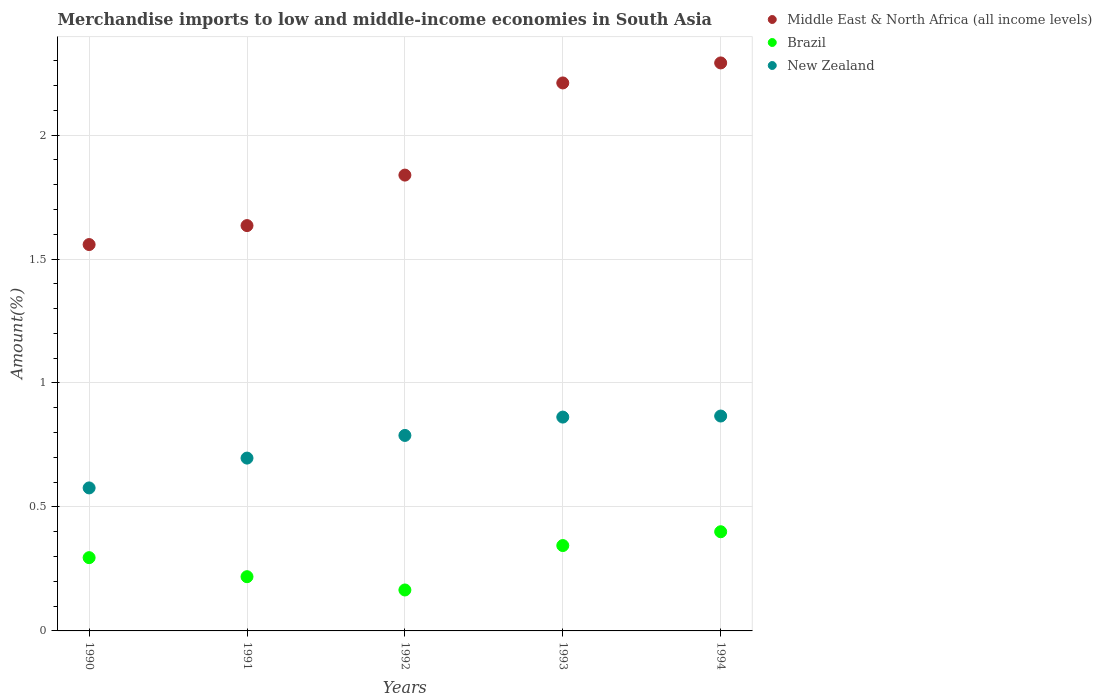What is the percentage of amount earned from merchandise imports in Brazil in 1993?
Give a very brief answer. 0.34. Across all years, what is the maximum percentage of amount earned from merchandise imports in Brazil?
Offer a very short reply. 0.4. Across all years, what is the minimum percentage of amount earned from merchandise imports in Middle East & North Africa (all income levels)?
Offer a very short reply. 1.56. In which year was the percentage of amount earned from merchandise imports in New Zealand maximum?
Your response must be concise. 1994. What is the total percentage of amount earned from merchandise imports in New Zealand in the graph?
Provide a succinct answer. 3.79. What is the difference between the percentage of amount earned from merchandise imports in Brazil in 1990 and that in 1993?
Ensure brevity in your answer.  -0.05. What is the difference between the percentage of amount earned from merchandise imports in New Zealand in 1991 and the percentage of amount earned from merchandise imports in Brazil in 1992?
Keep it short and to the point. 0.53. What is the average percentage of amount earned from merchandise imports in New Zealand per year?
Offer a terse response. 0.76. In the year 1993, what is the difference between the percentage of amount earned from merchandise imports in New Zealand and percentage of amount earned from merchandise imports in Brazil?
Provide a short and direct response. 0.52. In how many years, is the percentage of amount earned from merchandise imports in Middle East & North Africa (all income levels) greater than 1 %?
Make the answer very short. 5. What is the ratio of the percentage of amount earned from merchandise imports in New Zealand in 1992 to that in 1993?
Make the answer very short. 0.91. Is the difference between the percentage of amount earned from merchandise imports in New Zealand in 1991 and 1993 greater than the difference between the percentage of amount earned from merchandise imports in Brazil in 1991 and 1993?
Keep it short and to the point. No. What is the difference between the highest and the second highest percentage of amount earned from merchandise imports in New Zealand?
Keep it short and to the point. 0. What is the difference between the highest and the lowest percentage of amount earned from merchandise imports in Middle East & North Africa (all income levels)?
Ensure brevity in your answer.  0.73. In how many years, is the percentage of amount earned from merchandise imports in New Zealand greater than the average percentage of amount earned from merchandise imports in New Zealand taken over all years?
Your answer should be compact. 3. Is it the case that in every year, the sum of the percentage of amount earned from merchandise imports in Brazil and percentage of amount earned from merchandise imports in New Zealand  is greater than the percentage of amount earned from merchandise imports in Middle East & North Africa (all income levels)?
Your answer should be compact. No. Does the percentage of amount earned from merchandise imports in Brazil monotonically increase over the years?
Offer a terse response. No. Is the percentage of amount earned from merchandise imports in Middle East & North Africa (all income levels) strictly greater than the percentage of amount earned from merchandise imports in New Zealand over the years?
Provide a short and direct response. Yes. How many years are there in the graph?
Make the answer very short. 5. Are the values on the major ticks of Y-axis written in scientific E-notation?
Provide a succinct answer. No. Does the graph contain any zero values?
Your answer should be very brief. No. Where does the legend appear in the graph?
Keep it short and to the point. Top right. How are the legend labels stacked?
Provide a short and direct response. Vertical. What is the title of the graph?
Offer a terse response. Merchandise imports to low and middle-income economies in South Asia. What is the label or title of the Y-axis?
Offer a terse response. Amount(%). What is the Amount(%) of Middle East & North Africa (all income levels) in 1990?
Ensure brevity in your answer.  1.56. What is the Amount(%) in Brazil in 1990?
Provide a succinct answer. 0.3. What is the Amount(%) in New Zealand in 1990?
Ensure brevity in your answer.  0.58. What is the Amount(%) of Middle East & North Africa (all income levels) in 1991?
Your response must be concise. 1.63. What is the Amount(%) in Brazil in 1991?
Your response must be concise. 0.22. What is the Amount(%) of New Zealand in 1991?
Your response must be concise. 0.7. What is the Amount(%) in Middle East & North Africa (all income levels) in 1992?
Ensure brevity in your answer.  1.84. What is the Amount(%) of Brazil in 1992?
Provide a short and direct response. 0.17. What is the Amount(%) in New Zealand in 1992?
Your answer should be very brief. 0.79. What is the Amount(%) of Middle East & North Africa (all income levels) in 1993?
Ensure brevity in your answer.  2.21. What is the Amount(%) of Brazil in 1993?
Your response must be concise. 0.34. What is the Amount(%) in New Zealand in 1993?
Ensure brevity in your answer.  0.86. What is the Amount(%) of Middle East & North Africa (all income levels) in 1994?
Keep it short and to the point. 2.29. What is the Amount(%) in Brazil in 1994?
Ensure brevity in your answer.  0.4. What is the Amount(%) of New Zealand in 1994?
Ensure brevity in your answer.  0.87. Across all years, what is the maximum Amount(%) in Middle East & North Africa (all income levels)?
Give a very brief answer. 2.29. Across all years, what is the maximum Amount(%) in Brazil?
Provide a succinct answer. 0.4. Across all years, what is the maximum Amount(%) of New Zealand?
Give a very brief answer. 0.87. Across all years, what is the minimum Amount(%) of Middle East & North Africa (all income levels)?
Offer a terse response. 1.56. Across all years, what is the minimum Amount(%) of Brazil?
Make the answer very short. 0.17. Across all years, what is the minimum Amount(%) of New Zealand?
Ensure brevity in your answer.  0.58. What is the total Amount(%) of Middle East & North Africa (all income levels) in the graph?
Offer a very short reply. 9.53. What is the total Amount(%) in Brazil in the graph?
Your answer should be very brief. 1.42. What is the total Amount(%) of New Zealand in the graph?
Your answer should be very brief. 3.79. What is the difference between the Amount(%) in Middle East & North Africa (all income levels) in 1990 and that in 1991?
Give a very brief answer. -0.08. What is the difference between the Amount(%) in Brazil in 1990 and that in 1991?
Your response must be concise. 0.08. What is the difference between the Amount(%) of New Zealand in 1990 and that in 1991?
Your answer should be very brief. -0.12. What is the difference between the Amount(%) in Middle East & North Africa (all income levels) in 1990 and that in 1992?
Ensure brevity in your answer.  -0.28. What is the difference between the Amount(%) of Brazil in 1990 and that in 1992?
Your answer should be compact. 0.13. What is the difference between the Amount(%) in New Zealand in 1990 and that in 1992?
Make the answer very short. -0.21. What is the difference between the Amount(%) of Middle East & North Africa (all income levels) in 1990 and that in 1993?
Offer a very short reply. -0.65. What is the difference between the Amount(%) of Brazil in 1990 and that in 1993?
Give a very brief answer. -0.05. What is the difference between the Amount(%) in New Zealand in 1990 and that in 1993?
Offer a very short reply. -0.29. What is the difference between the Amount(%) in Middle East & North Africa (all income levels) in 1990 and that in 1994?
Your answer should be very brief. -0.73. What is the difference between the Amount(%) of Brazil in 1990 and that in 1994?
Ensure brevity in your answer.  -0.1. What is the difference between the Amount(%) in New Zealand in 1990 and that in 1994?
Offer a terse response. -0.29. What is the difference between the Amount(%) in Middle East & North Africa (all income levels) in 1991 and that in 1992?
Your answer should be compact. -0.2. What is the difference between the Amount(%) of Brazil in 1991 and that in 1992?
Your response must be concise. 0.05. What is the difference between the Amount(%) of New Zealand in 1991 and that in 1992?
Make the answer very short. -0.09. What is the difference between the Amount(%) of Middle East & North Africa (all income levels) in 1991 and that in 1993?
Your response must be concise. -0.58. What is the difference between the Amount(%) of Brazil in 1991 and that in 1993?
Offer a terse response. -0.13. What is the difference between the Amount(%) of New Zealand in 1991 and that in 1993?
Keep it short and to the point. -0.17. What is the difference between the Amount(%) of Middle East & North Africa (all income levels) in 1991 and that in 1994?
Your response must be concise. -0.66. What is the difference between the Amount(%) in Brazil in 1991 and that in 1994?
Your answer should be very brief. -0.18. What is the difference between the Amount(%) of New Zealand in 1991 and that in 1994?
Your response must be concise. -0.17. What is the difference between the Amount(%) of Middle East & North Africa (all income levels) in 1992 and that in 1993?
Provide a short and direct response. -0.37. What is the difference between the Amount(%) in Brazil in 1992 and that in 1993?
Keep it short and to the point. -0.18. What is the difference between the Amount(%) of New Zealand in 1992 and that in 1993?
Give a very brief answer. -0.07. What is the difference between the Amount(%) of Middle East & North Africa (all income levels) in 1992 and that in 1994?
Give a very brief answer. -0.45. What is the difference between the Amount(%) in Brazil in 1992 and that in 1994?
Offer a very short reply. -0.23. What is the difference between the Amount(%) in New Zealand in 1992 and that in 1994?
Provide a succinct answer. -0.08. What is the difference between the Amount(%) in Middle East & North Africa (all income levels) in 1993 and that in 1994?
Provide a succinct answer. -0.08. What is the difference between the Amount(%) of Brazil in 1993 and that in 1994?
Keep it short and to the point. -0.06. What is the difference between the Amount(%) of New Zealand in 1993 and that in 1994?
Give a very brief answer. -0. What is the difference between the Amount(%) of Middle East & North Africa (all income levels) in 1990 and the Amount(%) of Brazil in 1991?
Offer a terse response. 1.34. What is the difference between the Amount(%) in Middle East & North Africa (all income levels) in 1990 and the Amount(%) in New Zealand in 1991?
Your response must be concise. 0.86. What is the difference between the Amount(%) in Brazil in 1990 and the Amount(%) in New Zealand in 1991?
Ensure brevity in your answer.  -0.4. What is the difference between the Amount(%) of Middle East & North Africa (all income levels) in 1990 and the Amount(%) of Brazil in 1992?
Offer a very short reply. 1.39. What is the difference between the Amount(%) of Middle East & North Africa (all income levels) in 1990 and the Amount(%) of New Zealand in 1992?
Provide a short and direct response. 0.77. What is the difference between the Amount(%) in Brazil in 1990 and the Amount(%) in New Zealand in 1992?
Make the answer very short. -0.49. What is the difference between the Amount(%) of Middle East & North Africa (all income levels) in 1990 and the Amount(%) of Brazil in 1993?
Your answer should be very brief. 1.21. What is the difference between the Amount(%) in Middle East & North Africa (all income levels) in 1990 and the Amount(%) in New Zealand in 1993?
Provide a short and direct response. 0.7. What is the difference between the Amount(%) of Brazil in 1990 and the Amount(%) of New Zealand in 1993?
Offer a terse response. -0.57. What is the difference between the Amount(%) in Middle East & North Africa (all income levels) in 1990 and the Amount(%) in Brazil in 1994?
Provide a succinct answer. 1.16. What is the difference between the Amount(%) of Middle East & North Africa (all income levels) in 1990 and the Amount(%) of New Zealand in 1994?
Keep it short and to the point. 0.69. What is the difference between the Amount(%) in Brazil in 1990 and the Amount(%) in New Zealand in 1994?
Give a very brief answer. -0.57. What is the difference between the Amount(%) in Middle East & North Africa (all income levels) in 1991 and the Amount(%) in Brazil in 1992?
Keep it short and to the point. 1.47. What is the difference between the Amount(%) of Middle East & North Africa (all income levels) in 1991 and the Amount(%) of New Zealand in 1992?
Provide a succinct answer. 0.85. What is the difference between the Amount(%) in Brazil in 1991 and the Amount(%) in New Zealand in 1992?
Keep it short and to the point. -0.57. What is the difference between the Amount(%) in Middle East & North Africa (all income levels) in 1991 and the Amount(%) in Brazil in 1993?
Your answer should be very brief. 1.29. What is the difference between the Amount(%) in Middle East & North Africa (all income levels) in 1991 and the Amount(%) in New Zealand in 1993?
Your answer should be compact. 0.77. What is the difference between the Amount(%) in Brazil in 1991 and the Amount(%) in New Zealand in 1993?
Make the answer very short. -0.64. What is the difference between the Amount(%) of Middle East & North Africa (all income levels) in 1991 and the Amount(%) of Brazil in 1994?
Offer a terse response. 1.23. What is the difference between the Amount(%) of Middle East & North Africa (all income levels) in 1991 and the Amount(%) of New Zealand in 1994?
Your response must be concise. 0.77. What is the difference between the Amount(%) of Brazil in 1991 and the Amount(%) of New Zealand in 1994?
Your response must be concise. -0.65. What is the difference between the Amount(%) in Middle East & North Africa (all income levels) in 1992 and the Amount(%) in Brazil in 1993?
Your answer should be compact. 1.49. What is the difference between the Amount(%) of Middle East & North Africa (all income levels) in 1992 and the Amount(%) of New Zealand in 1993?
Keep it short and to the point. 0.98. What is the difference between the Amount(%) of Brazil in 1992 and the Amount(%) of New Zealand in 1993?
Provide a succinct answer. -0.7. What is the difference between the Amount(%) in Middle East & North Africa (all income levels) in 1992 and the Amount(%) in Brazil in 1994?
Offer a very short reply. 1.44. What is the difference between the Amount(%) of Middle East & North Africa (all income levels) in 1992 and the Amount(%) of New Zealand in 1994?
Your answer should be very brief. 0.97. What is the difference between the Amount(%) of Brazil in 1992 and the Amount(%) of New Zealand in 1994?
Ensure brevity in your answer.  -0.7. What is the difference between the Amount(%) of Middle East & North Africa (all income levels) in 1993 and the Amount(%) of Brazil in 1994?
Ensure brevity in your answer.  1.81. What is the difference between the Amount(%) in Middle East & North Africa (all income levels) in 1993 and the Amount(%) in New Zealand in 1994?
Give a very brief answer. 1.34. What is the difference between the Amount(%) in Brazil in 1993 and the Amount(%) in New Zealand in 1994?
Provide a succinct answer. -0.52. What is the average Amount(%) of Middle East & North Africa (all income levels) per year?
Your answer should be compact. 1.91. What is the average Amount(%) in Brazil per year?
Offer a terse response. 0.28. What is the average Amount(%) in New Zealand per year?
Your response must be concise. 0.76. In the year 1990, what is the difference between the Amount(%) in Middle East & North Africa (all income levels) and Amount(%) in Brazil?
Keep it short and to the point. 1.26. In the year 1990, what is the difference between the Amount(%) of Middle East & North Africa (all income levels) and Amount(%) of New Zealand?
Your response must be concise. 0.98. In the year 1990, what is the difference between the Amount(%) of Brazil and Amount(%) of New Zealand?
Your answer should be compact. -0.28. In the year 1991, what is the difference between the Amount(%) in Middle East & North Africa (all income levels) and Amount(%) in Brazil?
Provide a short and direct response. 1.42. In the year 1991, what is the difference between the Amount(%) of Middle East & North Africa (all income levels) and Amount(%) of New Zealand?
Offer a terse response. 0.94. In the year 1991, what is the difference between the Amount(%) in Brazil and Amount(%) in New Zealand?
Provide a short and direct response. -0.48. In the year 1992, what is the difference between the Amount(%) of Middle East & North Africa (all income levels) and Amount(%) of Brazil?
Offer a very short reply. 1.67. In the year 1992, what is the difference between the Amount(%) of Brazil and Amount(%) of New Zealand?
Provide a succinct answer. -0.62. In the year 1993, what is the difference between the Amount(%) of Middle East & North Africa (all income levels) and Amount(%) of Brazil?
Provide a short and direct response. 1.87. In the year 1993, what is the difference between the Amount(%) in Middle East & North Africa (all income levels) and Amount(%) in New Zealand?
Your answer should be very brief. 1.35. In the year 1993, what is the difference between the Amount(%) in Brazil and Amount(%) in New Zealand?
Ensure brevity in your answer.  -0.52. In the year 1994, what is the difference between the Amount(%) in Middle East & North Africa (all income levels) and Amount(%) in Brazil?
Give a very brief answer. 1.89. In the year 1994, what is the difference between the Amount(%) in Middle East & North Africa (all income levels) and Amount(%) in New Zealand?
Your answer should be very brief. 1.42. In the year 1994, what is the difference between the Amount(%) in Brazil and Amount(%) in New Zealand?
Ensure brevity in your answer.  -0.47. What is the ratio of the Amount(%) of Middle East & North Africa (all income levels) in 1990 to that in 1991?
Provide a succinct answer. 0.95. What is the ratio of the Amount(%) in Brazil in 1990 to that in 1991?
Your answer should be compact. 1.35. What is the ratio of the Amount(%) in New Zealand in 1990 to that in 1991?
Provide a short and direct response. 0.83. What is the ratio of the Amount(%) in Middle East & North Africa (all income levels) in 1990 to that in 1992?
Make the answer very short. 0.85. What is the ratio of the Amount(%) in Brazil in 1990 to that in 1992?
Provide a short and direct response. 1.79. What is the ratio of the Amount(%) of New Zealand in 1990 to that in 1992?
Make the answer very short. 0.73. What is the ratio of the Amount(%) of Middle East & North Africa (all income levels) in 1990 to that in 1993?
Provide a succinct answer. 0.71. What is the ratio of the Amount(%) in Brazil in 1990 to that in 1993?
Offer a very short reply. 0.86. What is the ratio of the Amount(%) of New Zealand in 1990 to that in 1993?
Ensure brevity in your answer.  0.67. What is the ratio of the Amount(%) of Middle East & North Africa (all income levels) in 1990 to that in 1994?
Your answer should be very brief. 0.68. What is the ratio of the Amount(%) of Brazil in 1990 to that in 1994?
Offer a terse response. 0.74. What is the ratio of the Amount(%) of New Zealand in 1990 to that in 1994?
Provide a succinct answer. 0.67. What is the ratio of the Amount(%) of Middle East & North Africa (all income levels) in 1991 to that in 1992?
Provide a succinct answer. 0.89. What is the ratio of the Amount(%) of Brazil in 1991 to that in 1992?
Keep it short and to the point. 1.32. What is the ratio of the Amount(%) in New Zealand in 1991 to that in 1992?
Offer a terse response. 0.88. What is the ratio of the Amount(%) of Middle East & North Africa (all income levels) in 1991 to that in 1993?
Ensure brevity in your answer.  0.74. What is the ratio of the Amount(%) in Brazil in 1991 to that in 1993?
Provide a short and direct response. 0.64. What is the ratio of the Amount(%) of New Zealand in 1991 to that in 1993?
Give a very brief answer. 0.81. What is the ratio of the Amount(%) in Middle East & North Africa (all income levels) in 1991 to that in 1994?
Your answer should be compact. 0.71. What is the ratio of the Amount(%) of Brazil in 1991 to that in 1994?
Your response must be concise. 0.55. What is the ratio of the Amount(%) in New Zealand in 1991 to that in 1994?
Keep it short and to the point. 0.8. What is the ratio of the Amount(%) in Middle East & North Africa (all income levels) in 1992 to that in 1993?
Make the answer very short. 0.83. What is the ratio of the Amount(%) of Brazil in 1992 to that in 1993?
Make the answer very short. 0.48. What is the ratio of the Amount(%) of New Zealand in 1992 to that in 1993?
Give a very brief answer. 0.91. What is the ratio of the Amount(%) of Middle East & North Africa (all income levels) in 1992 to that in 1994?
Your answer should be very brief. 0.8. What is the ratio of the Amount(%) in Brazil in 1992 to that in 1994?
Ensure brevity in your answer.  0.41. What is the ratio of the Amount(%) of New Zealand in 1992 to that in 1994?
Ensure brevity in your answer.  0.91. What is the ratio of the Amount(%) of Middle East & North Africa (all income levels) in 1993 to that in 1994?
Offer a terse response. 0.96. What is the ratio of the Amount(%) in Brazil in 1993 to that in 1994?
Your answer should be compact. 0.86. What is the difference between the highest and the second highest Amount(%) of Middle East & North Africa (all income levels)?
Your response must be concise. 0.08. What is the difference between the highest and the second highest Amount(%) of Brazil?
Make the answer very short. 0.06. What is the difference between the highest and the second highest Amount(%) of New Zealand?
Give a very brief answer. 0. What is the difference between the highest and the lowest Amount(%) of Middle East & North Africa (all income levels)?
Provide a succinct answer. 0.73. What is the difference between the highest and the lowest Amount(%) in Brazil?
Keep it short and to the point. 0.23. What is the difference between the highest and the lowest Amount(%) in New Zealand?
Offer a terse response. 0.29. 